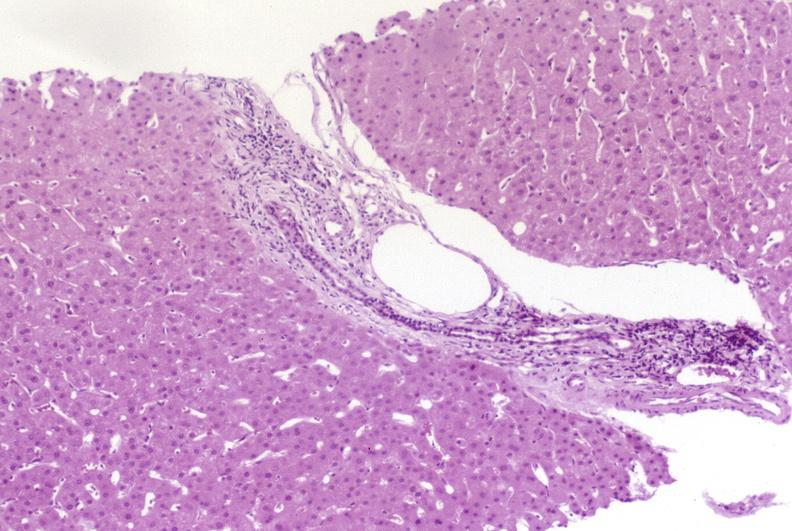what does this image show?
Answer the question using a single word or phrase. Resolving acute rejection 